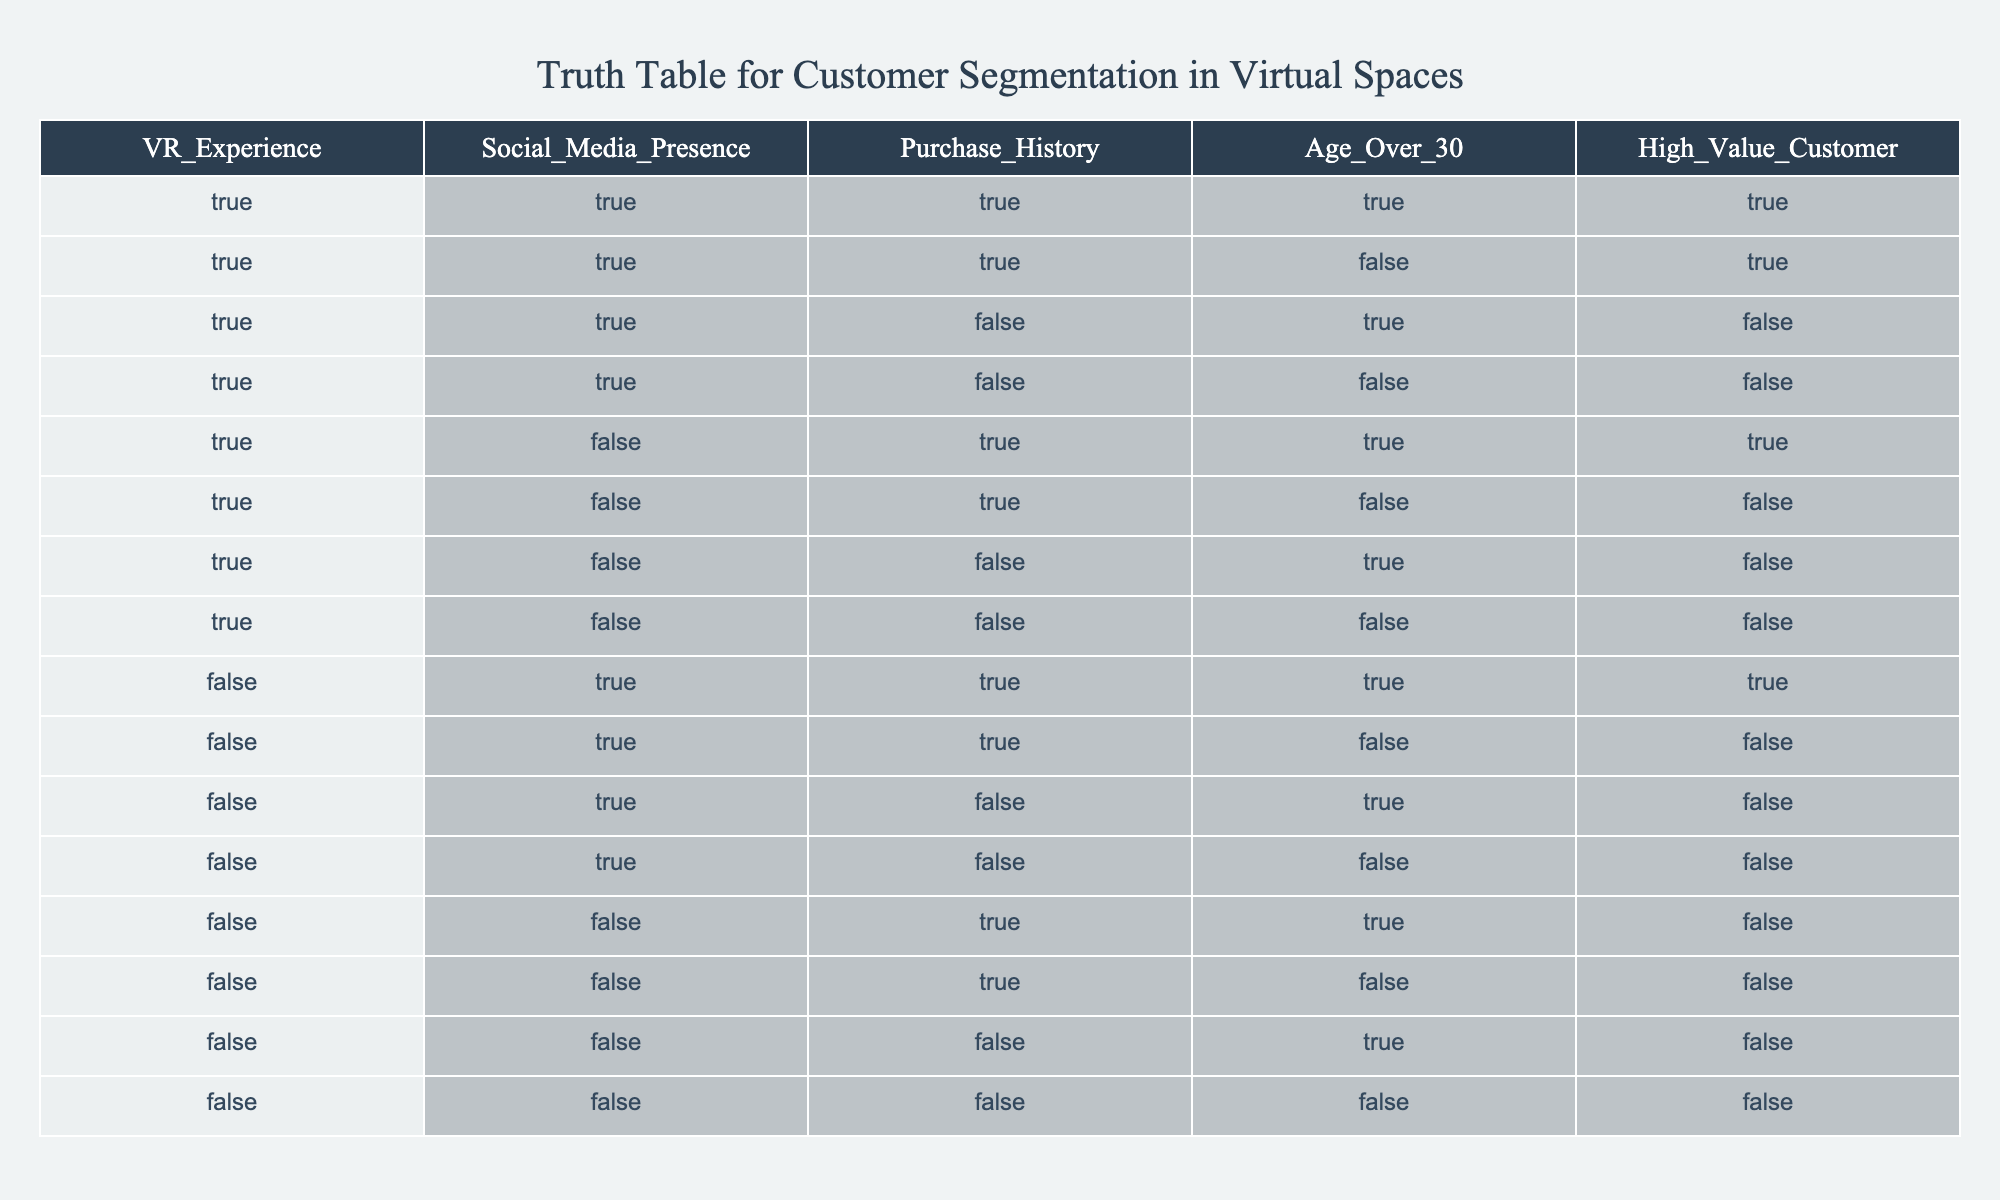What percentage of customers have a VR experience and also are high-value customers? There are 5 high-value customers. Out of these, 4 also have a VR experience (rows 1, 2, 5, and 9). To find the percentage: (4 high-value customers with VR experience / 5 total high-value customers) * 100 = 80%.
Answer: 80% How many customers aged over 30 are classified as high-value customers? There are 5 customers aged over 30 (rows 1, 3, 4, 9, and 12). Out of these, 4 are high-value customers (rows 1, 9). Therefore, the number of customers aged over 30 who are high-value is 2.
Answer: 2 Is a customer with no social media presence and no purchase history considered a high-value customer? Referring to the last row where both social media presence and purchase history are FALSE, this customer is not a high-value customer since the value is also FALSE.
Answer: No What is the total count of customers that have a high-value status and are under the age of 30? The total high-value customers are 5. Among them, we check their ages, finding that only 1 customer under 30 years is satisfied (row 6). Counting gives us a total of 1.
Answer: 1 How many customers have both a VR experience and a purchase history? From the table, we see that customer combinations can be found in rows where both VR experience and purchase history are TRUE. Rows 1, 2, 5, and 9 show 5 customers with both attributes. Thus, the total is 5 customers.
Answer: 5 Are there any customers who are high-value and aged over 30 without a VR experience? By checking the high-value customers, only row 1 and 4 have age over 30 and only row 1 has a VR experience. Thus, there is no such customer.
Answer: No What is the proportion of customers with a social media presence who are also high-value customers? Looking at rows with a social media presence, we find 8 customers total from the rows where this is TRUE. Out of these, 4 are high-value customers (rows 1, 2, 9, and 10). To find the proportion, it is (4 high-value customers / 8 total customers with social media presence) = 0.5.
Answer: 0.5 How many total unique combinations exist for customers with a VR experience and a purchase history? Counting the unique combinations with both parameters TRUE shows that there are 4 instances (rows 1, 2, 5, and 9). So, the unique combinations for both requirements is 4.
Answer: 4 